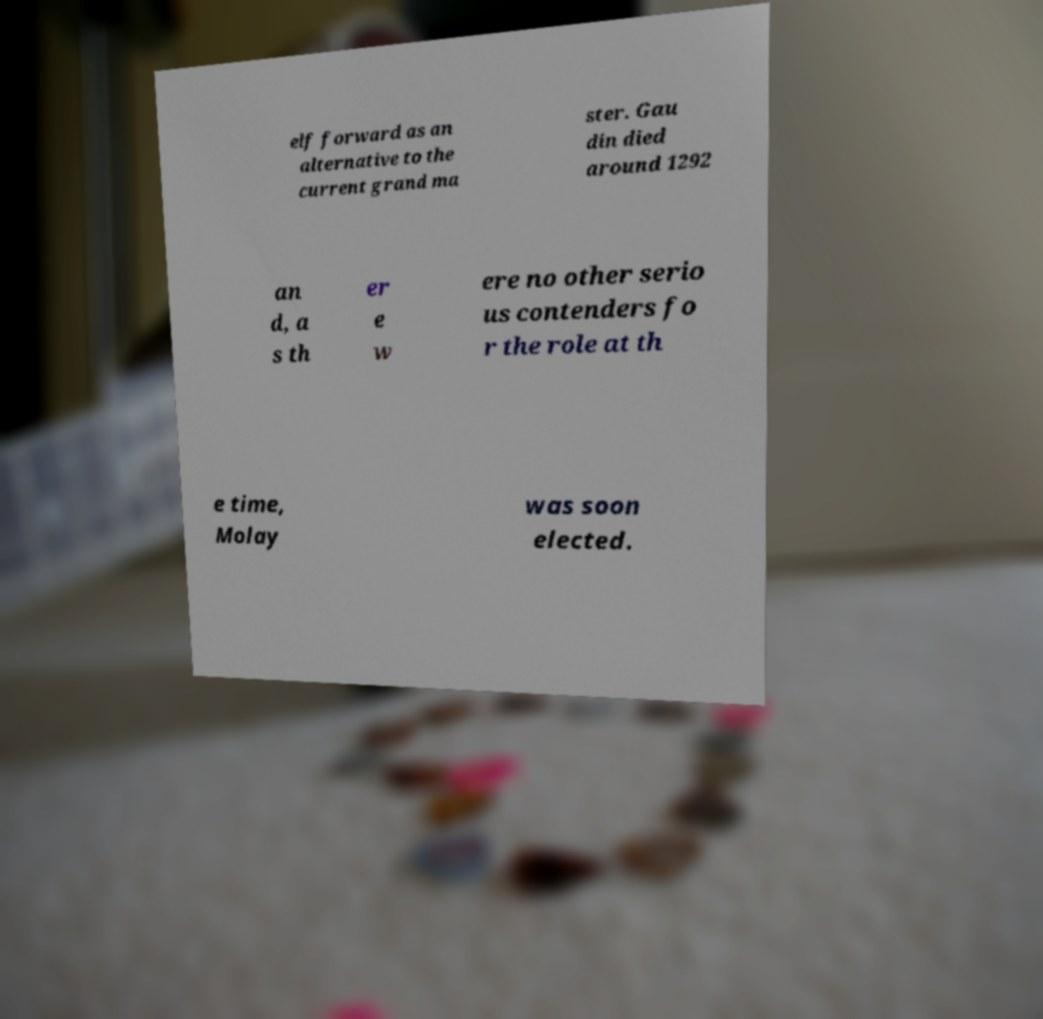Please identify and transcribe the text found in this image. elf forward as an alternative to the current grand ma ster. Gau din died around 1292 an d, a s th er e w ere no other serio us contenders fo r the role at th e time, Molay was soon elected. 